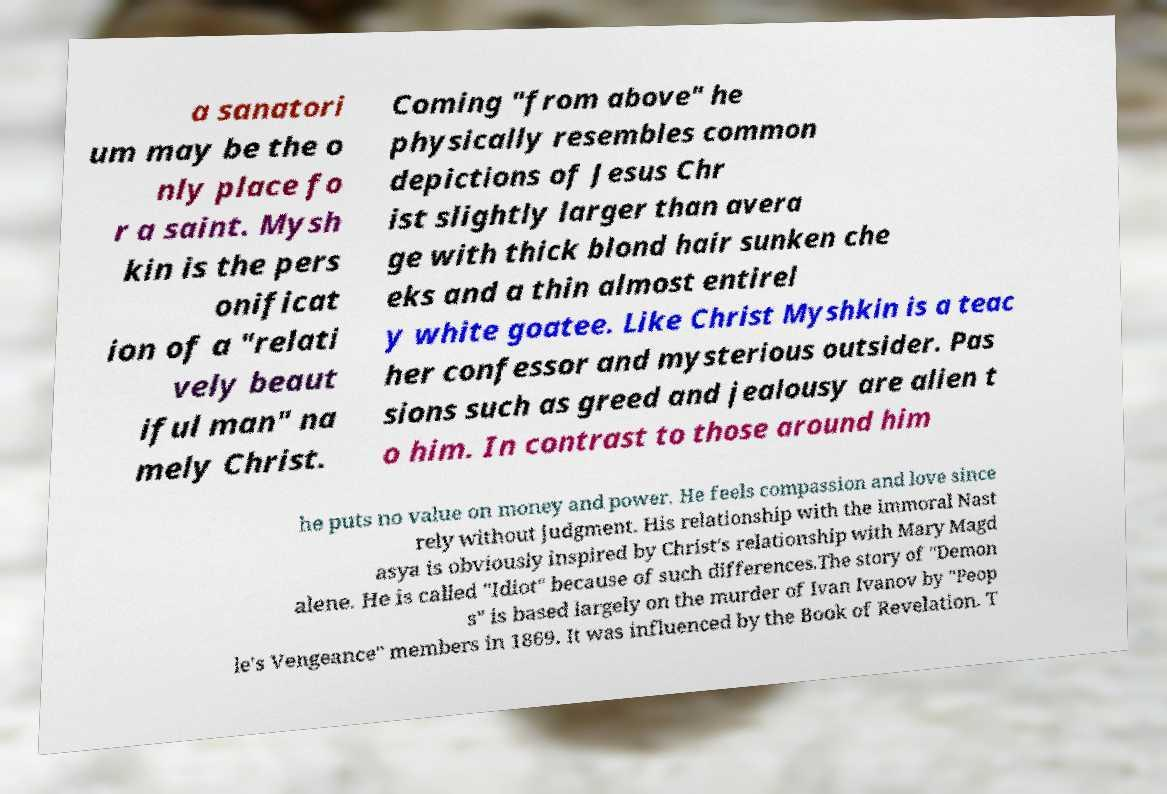I need the written content from this picture converted into text. Can you do that? a sanatori um may be the o nly place fo r a saint. Mysh kin is the pers onificat ion of a "relati vely beaut iful man" na mely Christ. Coming "from above" he physically resembles common depictions of Jesus Chr ist slightly larger than avera ge with thick blond hair sunken che eks and a thin almost entirel y white goatee. Like Christ Myshkin is a teac her confessor and mysterious outsider. Pas sions such as greed and jealousy are alien t o him. In contrast to those around him he puts no value on money and power. He feels compassion and love since rely without judgment. His relationship with the immoral Nast asya is obviously inspired by Christ's relationship with Mary Magd alene. He is called "Idiot" because of such differences.The story of "Demon s" is based largely on the murder of Ivan Ivanov by "Peop le's Vengeance" members in 1869. It was influenced by the Book of Revelation. T 